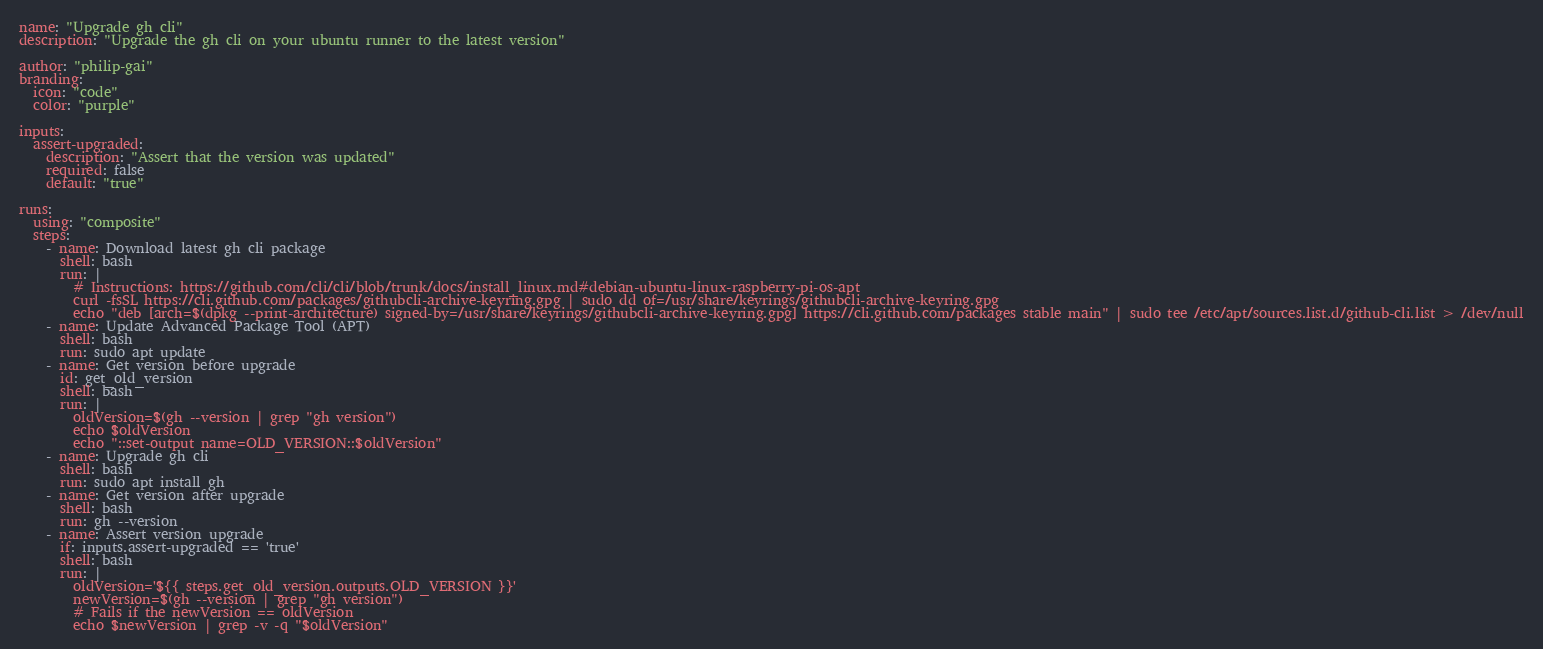<code> <loc_0><loc_0><loc_500><loc_500><_YAML_>name: "Upgrade gh cli"
description: "Upgrade the gh cli on your ubuntu runner to the latest version"

author: "philip-gai"
branding:
  icon: "code"
  color: "purple"

inputs:
  assert-upgraded:
    description: "Assert that the version was updated"
    required: false
    default: "true"

runs:
  using: "composite"
  steps:
    - name: Download latest gh cli package
      shell: bash
      run: |
        # Instructions: https://github.com/cli/cli/blob/trunk/docs/install_linux.md#debian-ubuntu-linux-raspberry-pi-os-apt 
        curl -fsSL https://cli.github.com/packages/githubcli-archive-keyring.gpg | sudo dd of=/usr/share/keyrings/githubcli-archive-keyring.gpg
        echo "deb [arch=$(dpkg --print-architecture) signed-by=/usr/share/keyrings/githubcli-archive-keyring.gpg] https://cli.github.com/packages stable main" | sudo tee /etc/apt/sources.list.d/github-cli.list > /dev/null
    - name: Update Advanced Package Tool (APT)
      shell: bash
      run: sudo apt update
    - name: Get version before upgrade
      id: get_old_version
      shell: bash
      run: |
        oldVersion=$(gh --version | grep "gh version")
        echo $oldVersion
        echo "::set-output name=OLD_VERSION::$oldVersion"
    - name: Upgrade gh cli
      shell: bash
      run: sudo apt install gh
    - name: Get version after upgrade
      shell: bash
      run: gh --version
    - name: Assert version upgrade
      if: inputs.assert-upgraded == 'true'
      shell: bash
      run: |
        oldVersion='${{ steps.get_old_version.outputs.OLD_VERSION }}'
        newVersion=$(gh --version | grep "gh version")
        # Fails if the newVersion == oldVersion
        echo $newVersion | grep -v -q "$oldVersion"
</code> 